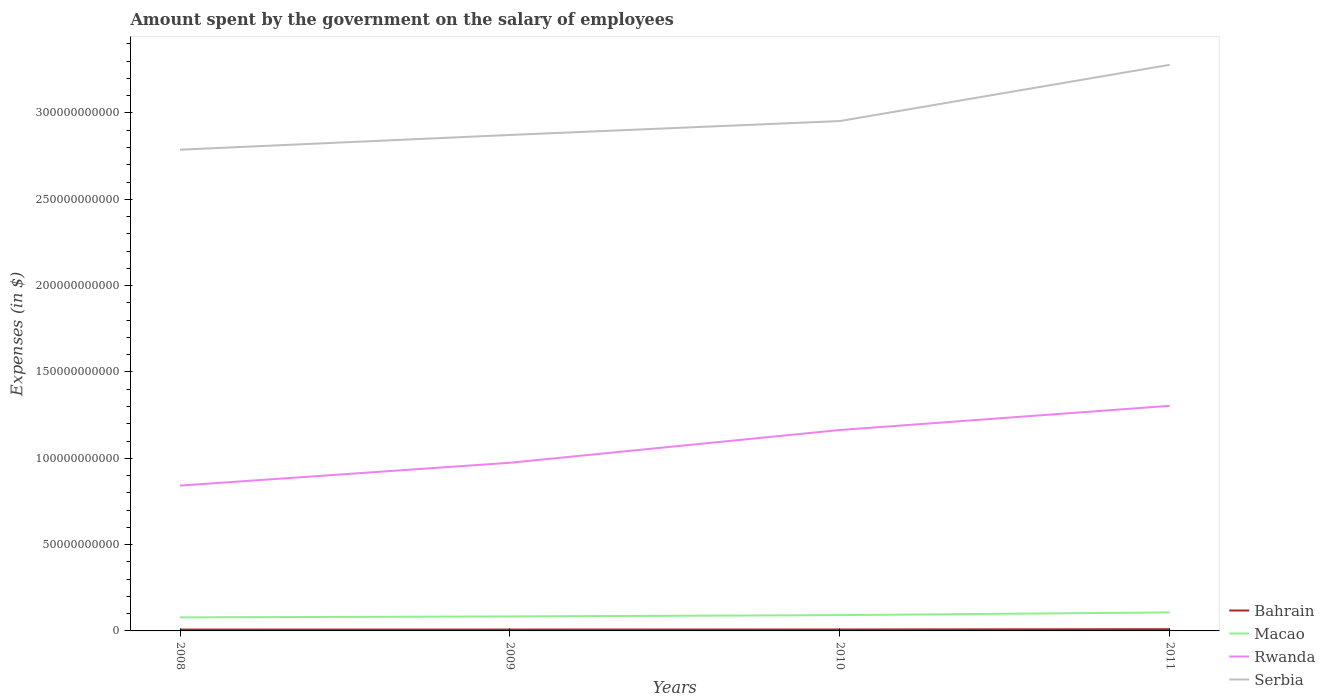Across all years, what is the maximum amount spent on the salary of employees by the government in Bahrain?
Ensure brevity in your answer.  7.89e+08. In which year was the amount spent on the salary of employees by the government in Serbia maximum?
Keep it short and to the point. 2008. What is the total amount spent on the salary of employees by the government in Serbia in the graph?
Ensure brevity in your answer.  -4.92e+1. What is the difference between the highest and the second highest amount spent on the salary of employees by the government in Rwanda?
Ensure brevity in your answer.  4.62e+1. What is the difference between two consecutive major ticks on the Y-axis?
Your response must be concise. 5.00e+1. Does the graph contain any zero values?
Provide a succinct answer. No. Does the graph contain grids?
Ensure brevity in your answer.  No. Where does the legend appear in the graph?
Offer a terse response. Bottom right. How many legend labels are there?
Ensure brevity in your answer.  4. What is the title of the graph?
Your response must be concise. Amount spent by the government on the salary of employees. What is the label or title of the X-axis?
Give a very brief answer. Years. What is the label or title of the Y-axis?
Make the answer very short. Expenses (in $). What is the Expenses (in $) in Bahrain in 2008?
Provide a short and direct response. 7.89e+08. What is the Expenses (in $) in Macao in 2008?
Keep it short and to the point. 7.85e+09. What is the Expenses (in $) in Rwanda in 2008?
Make the answer very short. 8.42e+1. What is the Expenses (in $) of Serbia in 2008?
Provide a short and direct response. 2.79e+11. What is the Expenses (in $) of Bahrain in 2009?
Provide a short and direct response. 8.00e+08. What is the Expenses (in $) in Macao in 2009?
Offer a terse response. 8.40e+09. What is the Expenses (in $) in Rwanda in 2009?
Provide a succinct answer. 9.74e+1. What is the Expenses (in $) of Serbia in 2009?
Your answer should be compact. 2.87e+11. What is the Expenses (in $) of Bahrain in 2010?
Keep it short and to the point. 8.32e+08. What is the Expenses (in $) in Macao in 2010?
Ensure brevity in your answer.  9.15e+09. What is the Expenses (in $) of Rwanda in 2010?
Provide a succinct answer. 1.16e+11. What is the Expenses (in $) in Serbia in 2010?
Provide a short and direct response. 2.95e+11. What is the Expenses (in $) in Bahrain in 2011?
Your answer should be compact. 1.00e+09. What is the Expenses (in $) in Macao in 2011?
Provide a short and direct response. 1.07e+1. What is the Expenses (in $) of Rwanda in 2011?
Offer a terse response. 1.30e+11. What is the Expenses (in $) of Serbia in 2011?
Offer a very short reply. 3.28e+11. Across all years, what is the maximum Expenses (in $) of Bahrain?
Your answer should be compact. 1.00e+09. Across all years, what is the maximum Expenses (in $) of Macao?
Offer a terse response. 1.07e+1. Across all years, what is the maximum Expenses (in $) in Rwanda?
Your response must be concise. 1.30e+11. Across all years, what is the maximum Expenses (in $) in Serbia?
Make the answer very short. 3.28e+11. Across all years, what is the minimum Expenses (in $) in Bahrain?
Provide a succinct answer. 7.89e+08. Across all years, what is the minimum Expenses (in $) of Macao?
Your response must be concise. 7.85e+09. Across all years, what is the minimum Expenses (in $) of Rwanda?
Your answer should be compact. 8.42e+1. Across all years, what is the minimum Expenses (in $) in Serbia?
Ensure brevity in your answer.  2.79e+11. What is the total Expenses (in $) of Bahrain in the graph?
Your answer should be compact. 3.43e+09. What is the total Expenses (in $) in Macao in the graph?
Provide a short and direct response. 3.61e+1. What is the total Expenses (in $) of Rwanda in the graph?
Keep it short and to the point. 4.28e+11. What is the total Expenses (in $) in Serbia in the graph?
Keep it short and to the point. 1.19e+12. What is the difference between the Expenses (in $) of Bahrain in 2008 and that in 2009?
Your answer should be compact. -1.12e+07. What is the difference between the Expenses (in $) of Macao in 2008 and that in 2009?
Your response must be concise. -5.54e+08. What is the difference between the Expenses (in $) in Rwanda in 2008 and that in 2009?
Ensure brevity in your answer.  -1.32e+1. What is the difference between the Expenses (in $) in Serbia in 2008 and that in 2009?
Provide a short and direct response. -8.54e+09. What is the difference between the Expenses (in $) of Bahrain in 2008 and that in 2010?
Keep it short and to the point. -4.38e+07. What is the difference between the Expenses (in $) of Macao in 2008 and that in 2010?
Offer a terse response. -1.30e+09. What is the difference between the Expenses (in $) in Rwanda in 2008 and that in 2010?
Provide a succinct answer. -3.22e+1. What is the difference between the Expenses (in $) in Serbia in 2008 and that in 2010?
Make the answer very short. -1.66e+1. What is the difference between the Expenses (in $) of Bahrain in 2008 and that in 2011?
Provide a short and direct response. -2.16e+08. What is the difference between the Expenses (in $) of Macao in 2008 and that in 2011?
Your response must be concise. -2.87e+09. What is the difference between the Expenses (in $) of Rwanda in 2008 and that in 2011?
Your answer should be compact. -4.62e+1. What is the difference between the Expenses (in $) in Serbia in 2008 and that in 2011?
Provide a succinct answer. -4.92e+1. What is the difference between the Expenses (in $) of Bahrain in 2009 and that in 2010?
Offer a very short reply. -3.25e+07. What is the difference between the Expenses (in $) of Macao in 2009 and that in 2010?
Your response must be concise. -7.49e+08. What is the difference between the Expenses (in $) of Rwanda in 2009 and that in 2010?
Make the answer very short. -1.90e+1. What is the difference between the Expenses (in $) in Serbia in 2009 and that in 2010?
Provide a succinct answer. -8.06e+09. What is the difference between the Expenses (in $) of Bahrain in 2009 and that in 2011?
Offer a terse response. -2.05e+08. What is the difference between the Expenses (in $) in Macao in 2009 and that in 2011?
Your response must be concise. -2.32e+09. What is the difference between the Expenses (in $) in Rwanda in 2009 and that in 2011?
Ensure brevity in your answer.  -3.30e+1. What is the difference between the Expenses (in $) in Serbia in 2009 and that in 2011?
Ensure brevity in your answer.  -4.06e+1. What is the difference between the Expenses (in $) of Bahrain in 2010 and that in 2011?
Offer a terse response. -1.73e+08. What is the difference between the Expenses (in $) in Macao in 2010 and that in 2011?
Provide a succinct answer. -1.57e+09. What is the difference between the Expenses (in $) of Rwanda in 2010 and that in 2011?
Make the answer very short. -1.40e+1. What is the difference between the Expenses (in $) in Serbia in 2010 and that in 2011?
Provide a succinct answer. -3.26e+1. What is the difference between the Expenses (in $) of Bahrain in 2008 and the Expenses (in $) of Macao in 2009?
Ensure brevity in your answer.  -7.61e+09. What is the difference between the Expenses (in $) in Bahrain in 2008 and the Expenses (in $) in Rwanda in 2009?
Give a very brief answer. -9.66e+1. What is the difference between the Expenses (in $) in Bahrain in 2008 and the Expenses (in $) in Serbia in 2009?
Make the answer very short. -2.86e+11. What is the difference between the Expenses (in $) of Macao in 2008 and the Expenses (in $) of Rwanda in 2009?
Your answer should be compact. -8.96e+1. What is the difference between the Expenses (in $) of Macao in 2008 and the Expenses (in $) of Serbia in 2009?
Give a very brief answer. -2.79e+11. What is the difference between the Expenses (in $) in Rwanda in 2008 and the Expenses (in $) in Serbia in 2009?
Offer a very short reply. -2.03e+11. What is the difference between the Expenses (in $) of Bahrain in 2008 and the Expenses (in $) of Macao in 2010?
Keep it short and to the point. -8.36e+09. What is the difference between the Expenses (in $) of Bahrain in 2008 and the Expenses (in $) of Rwanda in 2010?
Provide a short and direct response. -1.16e+11. What is the difference between the Expenses (in $) of Bahrain in 2008 and the Expenses (in $) of Serbia in 2010?
Give a very brief answer. -2.95e+11. What is the difference between the Expenses (in $) of Macao in 2008 and the Expenses (in $) of Rwanda in 2010?
Give a very brief answer. -1.09e+11. What is the difference between the Expenses (in $) in Macao in 2008 and the Expenses (in $) in Serbia in 2010?
Make the answer very short. -2.87e+11. What is the difference between the Expenses (in $) of Rwanda in 2008 and the Expenses (in $) of Serbia in 2010?
Keep it short and to the point. -2.11e+11. What is the difference between the Expenses (in $) of Bahrain in 2008 and the Expenses (in $) of Macao in 2011?
Keep it short and to the point. -9.93e+09. What is the difference between the Expenses (in $) in Bahrain in 2008 and the Expenses (in $) in Rwanda in 2011?
Provide a succinct answer. -1.30e+11. What is the difference between the Expenses (in $) in Bahrain in 2008 and the Expenses (in $) in Serbia in 2011?
Make the answer very short. -3.27e+11. What is the difference between the Expenses (in $) of Macao in 2008 and the Expenses (in $) of Rwanda in 2011?
Give a very brief answer. -1.23e+11. What is the difference between the Expenses (in $) in Macao in 2008 and the Expenses (in $) in Serbia in 2011?
Offer a terse response. -3.20e+11. What is the difference between the Expenses (in $) of Rwanda in 2008 and the Expenses (in $) of Serbia in 2011?
Give a very brief answer. -2.44e+11. What is the difference between the Expenses (in $) of Bahrain in 2009 and the Expenses (in $) of Macao in 2010?
Your answer should be very brief. -8.35e+09. What is the difference between the Expenses (in $) in Bahrain in 2009 and the Expenses (in $) in Rwanda in 2010?
Provide a short and direct response. -1.16e+11. What is the difference between the Expenses (in $) in Bahrain in 2009 and the Expenses (in $) in Serbia in 2010?
Give a very brief answer. -2.95e+11. What is the difference between the Expenses (in $) in Macao in 2009 and the Expenses (in $) in Rwanda in 2010?
Keep it short and to the point. -1.08e+11. What is the difference between the Expenses (in $) in Macao in 2009 and the Expenses (in $) in Serbia in 2010?
Your response must be concise. -2.87e+11. What is the difference between the Expenses (in $) in Rwanda in 2009 and the Expenses (in $) in Serbia in 2010?
Keep it short and to the point. -1.98e+11. What is the difference between the Expenses (in $) of Bahrain in 2009 and the Expenses (in $) of Macao in 2011?
Offer a very short reply. -9.92e+09. What is the difference between the Expenses (in $) in Bahrain in 2009 and the Expenses (in $) in Rwanda in 2011?
Your response must be concise. -1.30e+11. What is the difference between the Expenses (in $) in Bahrain in 2009 and the Expenses (in $) in Serbia in 2011?
Your answer should be very brief. -3.27e+11. What is the difference between the Expenses (in $) in Macao in 2009 and the Expenses (in $) in Rwanda in 2011?
Your answer should be very brief. -1.22e+11. What is the difference between the Expenses (in $) of Macao in 2009 and the Expenses (in $) of Serbia in 2011?
Ensure brevity in your answer.  -3.19e+11. What is the difference between the Expenses (in $) in Rwanda in 2009 and the Expenses (in $) in Serbia in 2011?
Offer a very short reply. -2.30e+11. What is the difference between the Expenses (in $) of Bahrain in 2010 and the Expenses (in $) of Macao in 2011?
Make the answer very short. -9.89e+09. What is the difference between the Expenses (in $) of Bahrain in 2010 and the Expenses (in $) of Rwanda in 2011?
Your response must be concise. -1.30e+11. What is the difference between the Expenses (in $) in Bahrain in 2010 and the Expenses (in $) in Serbia in 2011?
Offer a very short reply. -3.27e+11. What is the difference between the Expenses (in $) of Macao in 2010 and the Expenses (in $) of Rwanda in 2011?
Your response must be concise. -1.21e+11. What is the difference between the Expenses (in $) of Macao in 2010 and the Expenses (in $) of Serbia in 2011?
Give a very brief answer. -3.19e+11. What is the difference between the Expenses (in $) in Rwanda in 2010 and the Expenses (in $) in Serbia in 2011?
Provide a succinct answer. -2.12e+11. What is the average Expenses (in $) in Bahrain per year?
Ensure brevity in your answer.  8.56e+08. What is the average Expenses (in $) of Macao per year?
Make the answer very short. 9.03e+09. What is the average Expenses (in $) of Rwanda per year?
Offer a very short reply. 1.07e+11. What is the average Expenses (in $) in Serbia per year?
Offer a terse response. 2.97e+11. In the year 2008, what is the difference between the Expenses (in $) of Bahrain and Expenses (in $) of Macao?
Offer a very short reply. -7.06e+09. In the year 2008, what is the difference between the Expenses (in $) of Bahrain and Expenses (in $) of Rwanda?
Provide a short and direct response. -8.34e+1. In the year 2008, what is the difference between the Expenses (in $) of Bahrain and Expenses (in $) of Serbia?
Keep it short and to the point. -2.78e+11. In the year 2008, what is the difference between the Expenses (in $) in Macao and Expenses (in $) in Rwanda?
Your answer should be very brief. -7.63e+1. In the year 2008, what is the difference between the Expenses (in $) of Macao and Expenses (in $) of Serbia?
Ensure brevity in your answer.  -2.71e+11. In the year 2008, what is the difference between the Expenses (in $) of Rwanda and Expenses (in $) of Serbia?
Ensure brevity in your answer.  -1.95e+11. In the year 2009, what is the difference between the Expenses (in $) of Bahrain and Expenses (in $) of Macao?
Offer a terse response. -7.60e+09. In the year 2009, what is the difference between the Expenses (in $) of Bahrain and Expenses (in $) of Rwanda?
Provide a succinct answer. -9.66e+1. In the year 2009, what is the difference between the Expenses (in $) in Bahrain and Expenses (in $) in Serbia?
Provide a short and direct response. -2.86e+11. In the year 2009, what is the difference between the Expenses (in $) of Macao and Expenses (in $) of Rwanda?
Provide a succinct answer. -8.90e+1. In the year 2009, what is the difference between the Expenses (in $) of Macao and Expenses (in $) of Serbia?
Your answer should be very brief. -2.79e+11. In the year 2009, what is the difference between the Expenses (in $) in Rwanda and Expenses (in $) in Serbia?
Give a very brief answer. -1.90e+11. In the year 2010, what is the difference between the Expenses (in $) of Bahrain and Expenses (in $) of Macao?
Ensure brevity in your answer.  -8.32e+09. In the year 2010, what is the difference between the Expenses (in $) of Bahrain and Expenses (in $) of Rwanda?
Keep it short and to the point. -1.16e+11. In the year 2010, what is the difference between the Expenses (in $) in Bahrain and Expenses (in $) in Serbia?
Ensure brevity in your answer.  -2.94e+11. In the year 2010, what is the difference between the Expenses (in $) in Macao and Expenses (in $) in Rwanda?
Give a very brief answer. -1.07e+11. In the year 2010, what is the difference between the Expenses (in $) of Macao and Expenses (in $) of Serbia?
Give a very brief answer. -2.86e+11. In the year 2010, what is the difference between the Expenses (in $) in Rwanda and Expenses (in $) in Serbia?
Your answer should be compact. -1.79e+11. In the year 2011, what is the difference between the Expenses (in $) of Bahrain and Expenses (in $) of Macao?
Provide a succinct answer. -9.71e+09. In the year 2011, what is the difference between the Expenses (in $) of Bahrain and Expenses (in $) of Rwanda?
Keep it short and to the point. -1.29e+11. In the year 2011, what is the difference between the Expenses (in $) of Bahrain and Expenses (in $) of Serbia?
Your response must be concise. -3.27e+11. In the year 2011, what is the difference between the Expenses (in $) of Macao and Expenses (in $) of Rwanda?
Give a very brief answer. -1.20e+11. In the year 2011, what is the difference between the Expenses (in $) of Macao and Expenses (in $) of Serbia?
Make the answer very short. -3.17e+11. In the year 2011, what is the difference between the Expenses (in $) in Rwanda and Expenses (in $) in Serbia?
Your answer should be compact. -1.98e+11. What is the ratio of the Expenses (in $) in Bahrain in 2008 to that in 2009?
Offer a very short reply. 0.99. What is the ratio of the Expenses (in $) in Macao in 2008 to that in 2009?
Your response must be concise. 0.93. What is the ratio of the Expenses (in $) of Rwanda in 2008 to that in 2009?
Provide a short and direct response. 0.86. What is the ratio of the Expenses (in $) in Serbia in 2008 to that in 2009?
Your answer should be compact. 0.97. What is the ratio of the Expenses (in $) in Macao in 2008 to that in 2010?
Your response must be concise. 0.86. What is the ratio of the Expenses (in $) in Rwanda in 2008 to that in 2010?
Give a very brief answer. 0.72. What is the ratio of the Expenses (in $) in Serbia in 2008 to that in 2010?
Offer a very short reply. 0.94. What is the ratio of the Expenses (in $) in Bahrain in 2008 to that in 2011?
Offer a terse response. 0.78. What is the ratio of the Expenses (in $) of Macao in 2008 to that in 2011?
Make the answer very short. 0.73. What is the ratio of the Expenses (in $) of Rwanda in 2008 to that in 2011?
Provide a succinct answer. 0.65. What is the ratio of the Expenses (in $) of Serbia in 2008 to that in 2011?
Offer a terse response. 0.85. What is the ratio of the Expenses (in $) in Bahrain in 2009 to that in 2010?
Your answer should be compact. 0.96. What is the ratio of the Expenses (in $) in Macao in 2009 to that in 2010?
Provide a short and direct response. 0.92. What is the ratio of the Expenses (in $) in Rwanda in 2009 to that in 2010?
Give a very brief answer. 0.84. What is the ratio of the Expenses (in $) in Serbia in 2009 to that in 2010?
Your response must be concise. 0.97. What is the ratio of the Expenses (in $) of Bahrain in 2009 to that in 2011?
Give a very brief answer. 0.8. What is the ratio of the Expenses (in $) in Macao in 2009 to that in 2011?
Make the answer very short. 0.78. What is the ratio of the Expenses (in $) in Rwanda in 2009 to that in 2011?
Your answer should be compact. 0.75. What is the ratio of the Expenses (in $) of Serbia in 2009 to that in 2011?
Your response must be concise. 0.88. What is the ratio of the Expenses (in $) in Bahrain in 2010 to that in 2011?
Your answer should be compact. 0.83. What is the ratio of the Expenses (in $) of Macao in 2010 to that in 2011?
Ensure brevity in your answer.  0.85. What is the ratio of the Expenses (in $) of Rwanda in 2010 to that in 2011?
Your answer should be very brief. 0.89. What is the ratio of the Expenses (in $) of Serbia in 2010 to that in 2011?
Provide a short and direct response. 0.9. What is the difference between the highest and the second highest Expenses (in $) in Bahrain?
Keep it short and to the point. 1.73e+08. What is the difference between the highest and the second highest Expenses (in $) of Macao?
Your answer should be compact. 1.57e+09. What is the difference between the highest and the second highest Expenses (in $) of Rwanda?
Give a very brief answer. 1.40e+1. What is the difference between the highest and the second highest Expenses (in $) of Serbia?
Offer a terse response. 3.26e+1. What is the difference between the highest and the lowest Expenses (in $) in Bahrain?
Ensure brevity in your answer.  2.16e+08. What is the difference between the highest and the lowest Expenses (in $) of Macao?
Give a very brief answer. 2.87e+09. What is the difference between the highest and the lowest Expenses (in $) in Rwanda?
Ensure brevity in your answer.  4.62e+1. What is the difference between the highest and the lowest Expenses (in $) of Serbia?
Give a very brief answer. 4.92e+1. 